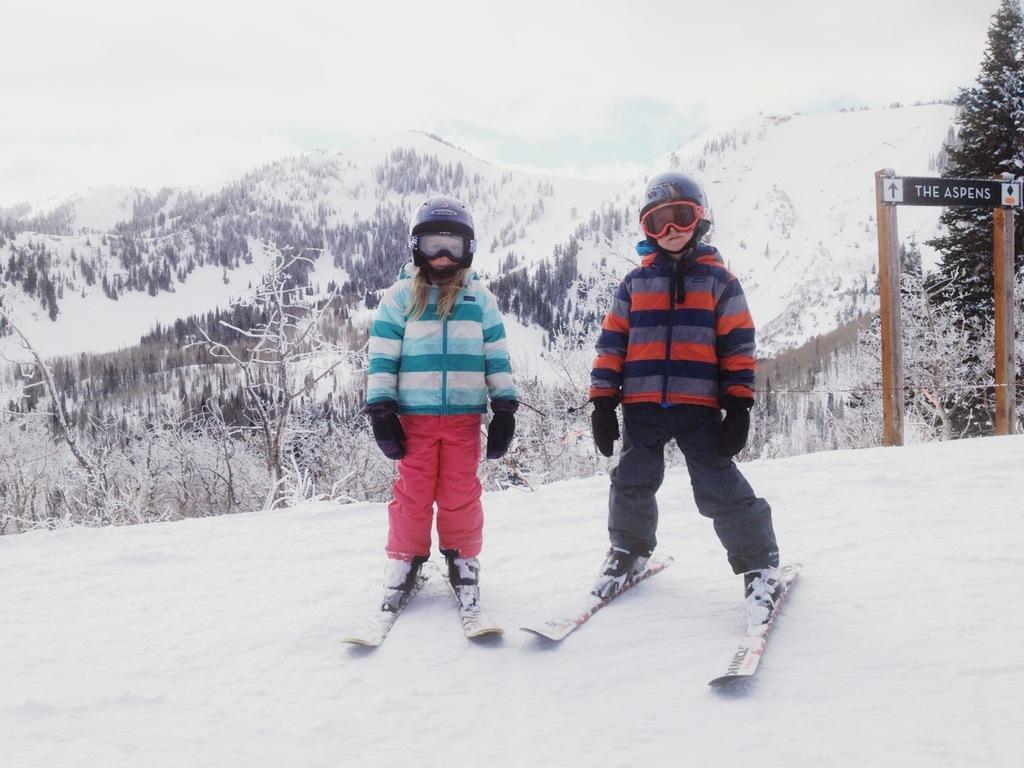How would you summarize this image in a sentence or two? There are two children in different color dresses standing on the snow boards. Which are on the snow surface of a hill. In the background, there are plants and trees on the hill, there are mountains and there are clouds in the sky. 